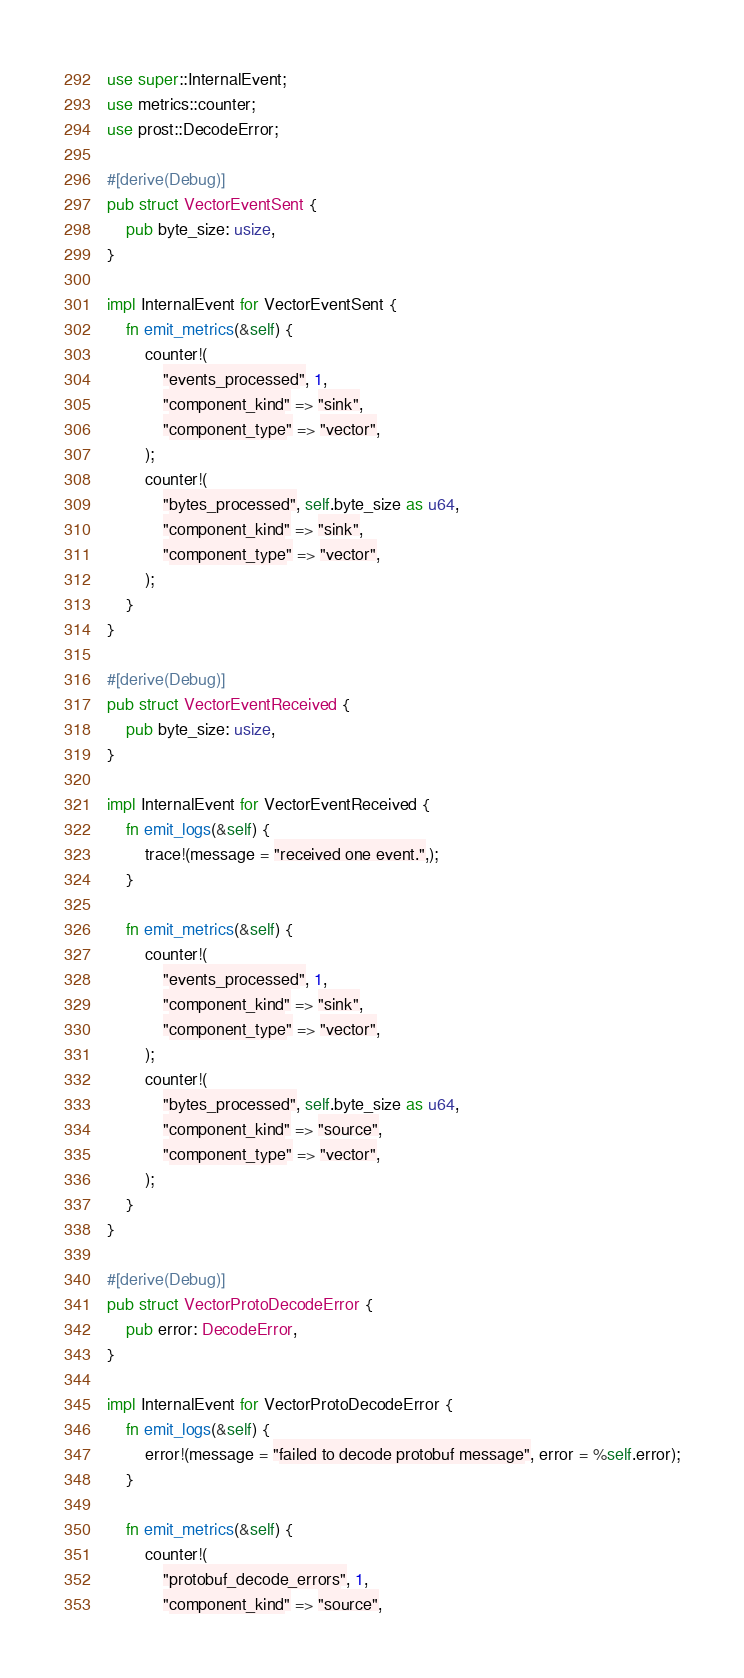<code> <loc_0><loc_0><loc_500><loc_500><_Rust_>use super::InternalEvent;
use metrics::counter;
use prost::DecodeError;

#[derive(Debug)]
pub struct VectorEventSent {
    pub byte_size: usize,
}

impl InternalEvent for VectorEventSent {
    fn emit_metrics(&self) {
        counter!(
            "events_processed", 1,
            "component_kind" => "sink",
            "component_type" => "vector",
        );
        counter!(
            "bytes_processed", self.byte_size as u64,
            "component_kind" => "sink",
            "component_type" => "vector",
        );
    }
}

#[derive(Debug)]
pub struct VectorEventReceived {
    pub byte_size: usize,
}

impl InternalEvent for VectorEventReceived {
    fn emit_logs(&self) {
        trace!(message = "received one event.",);
    }

    fn emit_metrics(&self) {
        counter!(
            "events_processed", 1,
            "component_kind" => "sink",
            "component_type" => "vector",
        );
        counter!(
            "bytes_processed", self.byte_size as u64,
            "component_kind" => "source",
            "component_type" => "vector",
        );
    }
}

#[derive(Debug)]
pub struct VectorProtoDecodeError {
    pub error: DecodeError,
}

impl InternalEvent for VectorProtoDecodeError {
    fn emit_logs(&self) {
        error!(message = "failed to decode protobuf message", error = %self.error);
    }

    fn emit_metrics(&self) {
        counter!(
            "protobuf_decode_errors", 1,
            "component_kind" => "source",</code> 